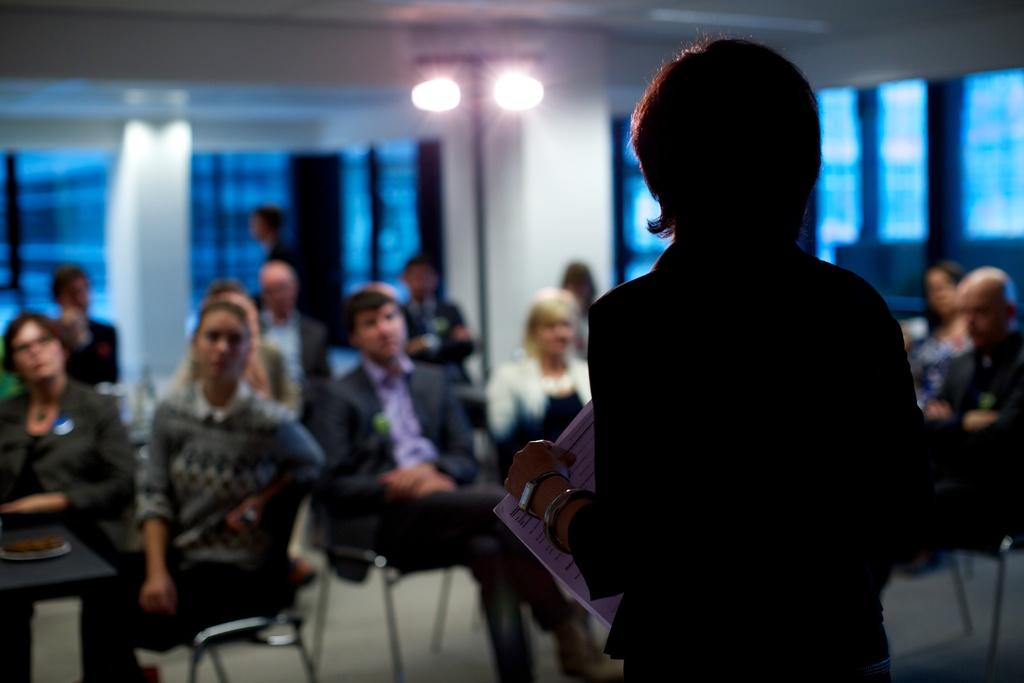What is the main subject of the image? There is a person in the image. What is the person holding or interacting with in the image? The person is holding papers in the image. What can be seen in the background of the image? In the background of the image, there are persons, chairs, lights, a wall, windows, and other objects. What type of country is depicted in the image? There is no country depicted in the image; it features a person holding papers and a background with various objects and elements. Can you tell me how many cannons are visible in the image? There are no cannons present in the image. 